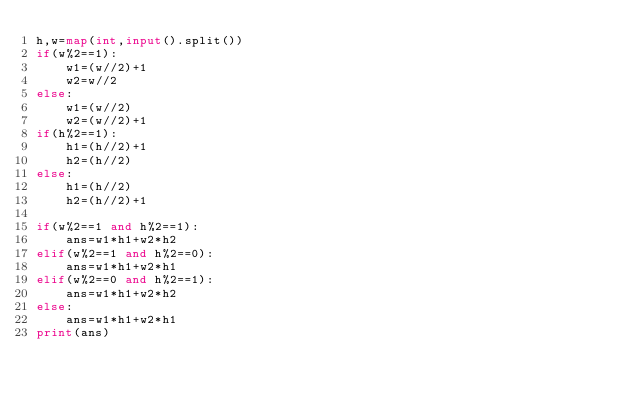<code> <loc_0><loc_0><loc_500><loc_500><_Python_>h,w=map(int,input().split())
if(w%2==1):
    w1=(w//2)+1
    w2=w//2
else:
    w1=(w//2)
    w2=(w//2)+1
if(h%2==1):
    h1=(h//2)+1
    h2=(h//2)
else:
    h1=(h//2)
    h2=(h//2)+1

if(w%2==1 and h%2==1):
    ans=w1*h1+w2*h2
elif(w%2==1 and h%2==0):
    ans=w1*h1+w2*h1
elif(w%2==0 and h%2==1):
    ans=w1*h1+w2*h2
else:
    ans=w1*h1+w2*h1
print(ans)</code> 